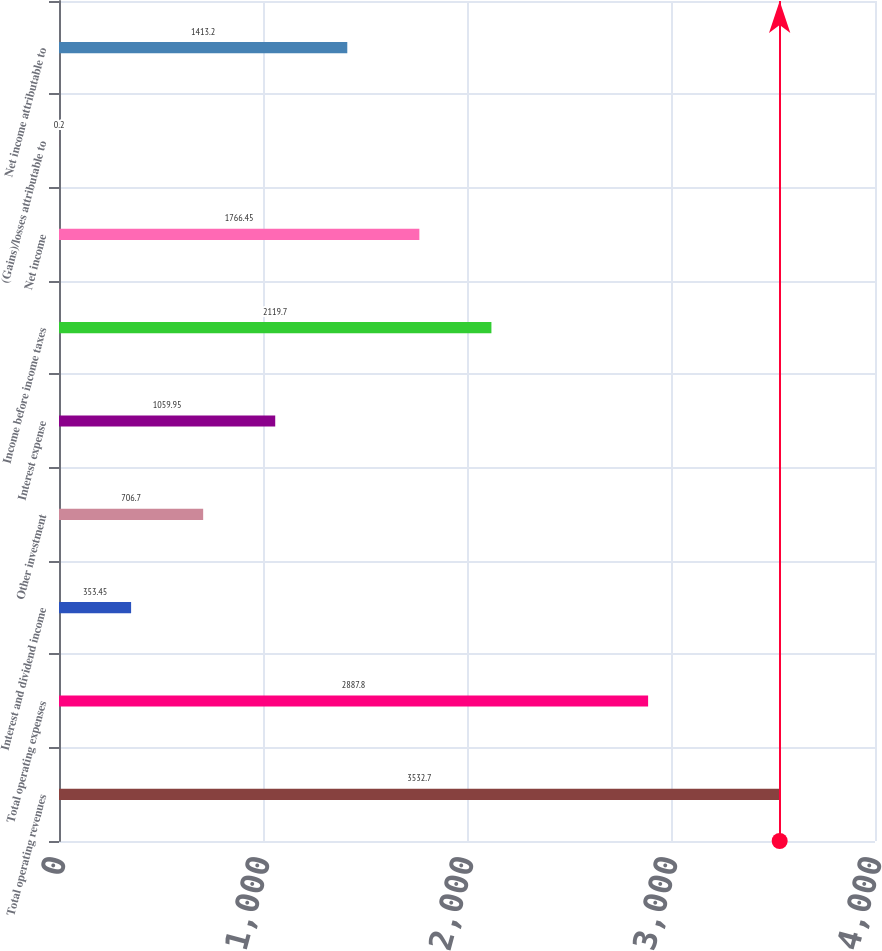<chart> <loc_0><loc_0><loc_500><loc_500><bar_chart><fcel>Total operating revenues<fcel>Total operating expenses<fcel>Interest and dividend income<fcel>Other investment<fcel>Interest expense<fcel>Income before income taxes<fcel>Net income<fcel>(Gains)/losses attributable to<fcel>Net income attributable to<nl><fcel>3532.7<fcel>2887.8<fcel>353.45<fcel>706.7<fcel>1059.95<fcel>2119.7<fcel>1766.45<fcel>0.2<fcel>1413.2<nl></chart> 